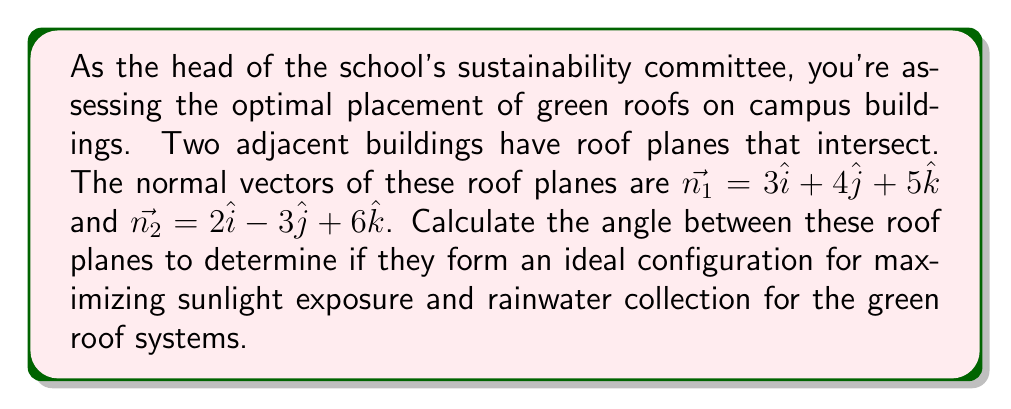Teach me how to tackle this problem. To find the angle between two planes, we can use the dot product of their normal vectors. The formula for the angle $\theta$ between two planes with normal vectors $\vec{n_1}$ and $\vec{n_2}$ is:

$$\cos \theta = \frac{|\vec{n_1} \cdot \vec{n_2}|}{|\vec{n_1}||\vec{n_2}|}$$

Let's solve this step-by-step:

1) First, calculate the dot product $\vec{n_1} \cdot \vec{n_2}$:
   $$\vec{n_1} \cdot \vec{n_2} = (3)(2) + (4)(-3) + (5)(6) = 6 - 12 + 30 = 24$$

2) Calculate the magnitudes of $\vec{n_1}$ and $\vec{n_2}$:
   $$|\vec{n_1}| = \sqrt{3^2 + 4^2 + 5^2} = \sqrt{9 + 16 + 25} = \sqrt{50}$$
   $$|\vec{n_2}| = \sqrt{2^2 + (-3)^2 + 6^2} = \sqrt{4 + 9 + 36} = \sqrt{49} = 7$$

3) Now, substitute these values into the formula:
   $$\cos \theta = \frac{|24|}{\sqrt{50} \cdot 7} = \frac{24}{\sqrt{50} \cdot 7}$$

4) Simplify:
   $$\cos \theta = \frac{24}{7\sqrt{50}} = \frac{24\sqrt{2}}{70}$$

5) To find $\theta$, take the inverse cosine (arccos) of both sides:
   $$\theta = \arccos(\frac{24\sqrt{2}}{70})$$

6) Using a calculator, we can evaluate this:
   $$\theta \approx 0.9553 \text{ radians}$$

7) Convert to degrees:
   $$\theta \approx 0.9553 \cdot \frac{180}{\pi} \approx 54.74°$$
Answer: $54.74°$ 